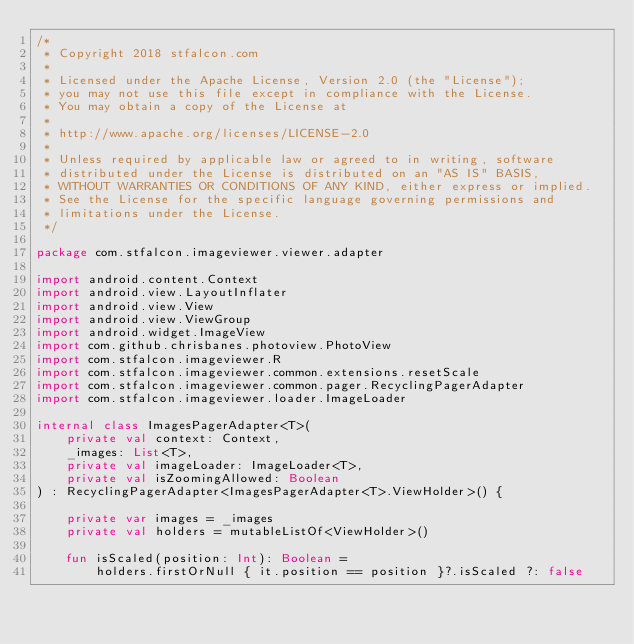Convert code to text. <code><loc_0><loc_0><loc_500><loc_500><_Kotlin_>/*
 * Copyright 2018 stfalcon.com
 *
 * Licensed under the Apache License, Version 2.0 (the "License");
 * you may not use this file except in compliance with the License.
 * You may obtain a copy of the License at
 *
 * http://www.apache.org/licenses/LICENSE-2.0
 *
 * Unless required by applicable law or agreed to in writing, software
 * distributed under the License is distributed on an "AS IS" BASIS,
 * WITHOUT WARRANTIES OR CONDITIONS OF ANY KIND, either express or implied.
 * See the License for the specific language governing permissions and
 * limitations under the License.
 */

package com.stfalcon.imageviewer.viewer.adapter

import android.content.Context
import android.view.LayoutInflater
import android.view.View
import android.view.ViewGroup
import android.widget.ImageView
import com.github.chrisbanes.photoview.PhotoView
import com.stfalcon.imageviewer.R
import com.stfalcon.imageviewer.common.extensions.resetScale
import com.stfalcon.imageviewer.common.pager.RecyclingPagerAdapter
import com.stfalcon.imageviewer.loader.ImageLoader

internal class ImagesPagerAdapter<T>(
    private val context: Context,
    _images: List<T>,
    private val imageLoader: ImageLoader<T>,
    private val isZoomingAllowed: Boolean
) : RecyclingPagerAdapter<ImagesPagerAdapter<T>.ViewHolder>() {

    private var images = _images
    private val holders = mutableListOf<ViewHolder>()

    fun isScaled(position: Int): Boolean =
        holders.firstOrNull { it.position == position }?.isScaled ?: false
</code> 